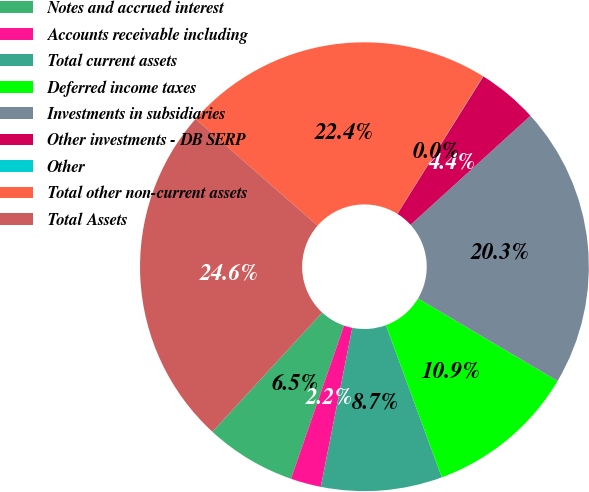Convert chart. <chart><loc_0><loc_0><loc_500><loc_500><pie_chart><fcel>Notes and accrued interest<fcel>Accounts receivable including<fcel>Total current assets<fcel>Deferred income taxes<fcel>Investments in subsidiaries<fcel>Other investments - DB SERP<fcel>Other<fcel>Total other non-current assets<fcel>Total Assets<nl><fcel>6.54%<fcel>2.19%<fcel>8.72%<fcel>10.89%<fcel>20.25%<fcel>4.37%<fcel>0.02%<fcel>22.42%<fcel>24.6%<nl></chart> 